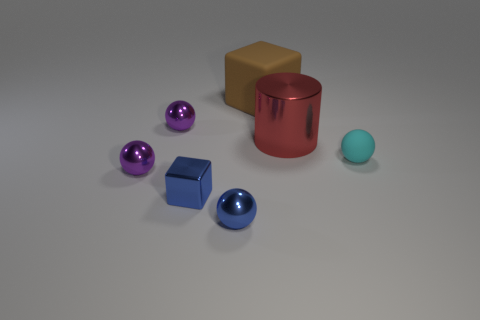Subtract all blue balls. How many balls are left? 3 Add 1 purple things. How many objects exist? 8 Subtract all gray balls. Subtract all purple cubes. How many balls are left? 4 Subtract all cubes. How many objects are left? 5 Subtract all red things. Subtract all small gray objects. How many objects are left? 6 Add 3 big brown rubber blocks. How many big brown rubber blocks are left? 4 Add 3 tiny shiny blocks. How many tiny shiny blocks exist? 4 Subtract 0 red cubes. How many objects are left? 7 